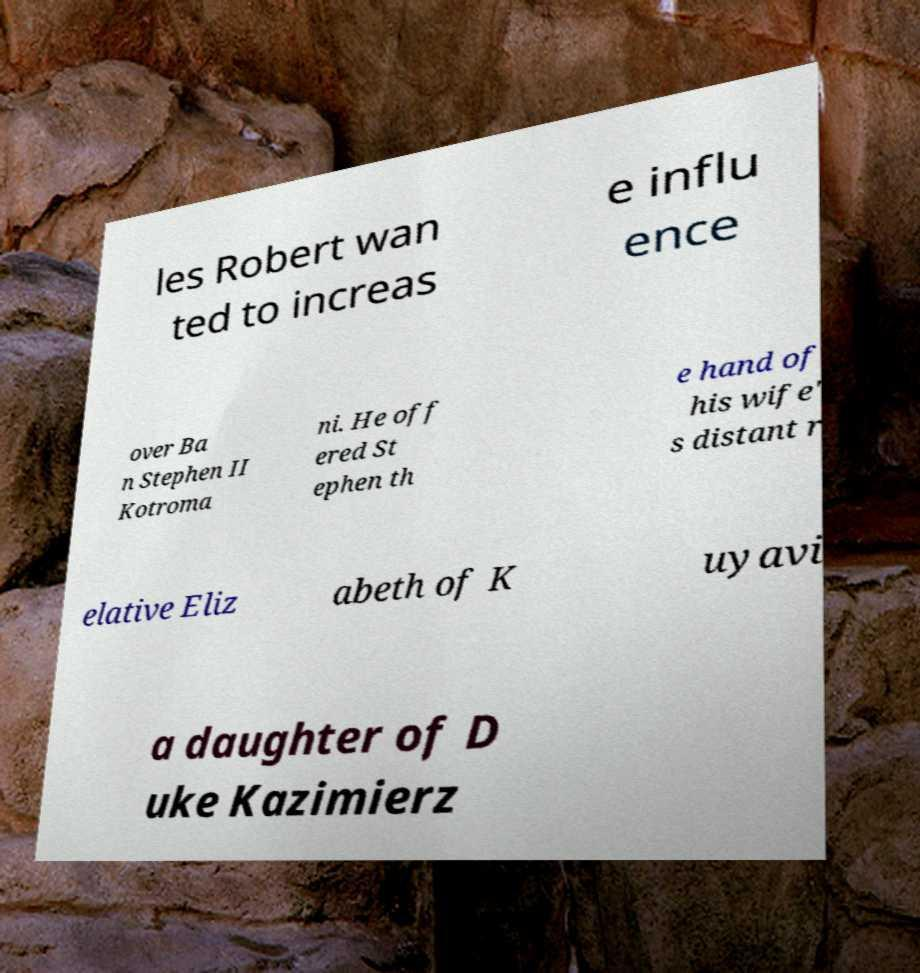Please identify and transcribe the text found in this image. les Robert wan ted to increas e influ ence over Ba n Stephen II Kotroma ni. He off ered St ephen th e hand of his wife' s distant r elative Eliz abeth of K uyavi a daughter of D uke Kazimierz 